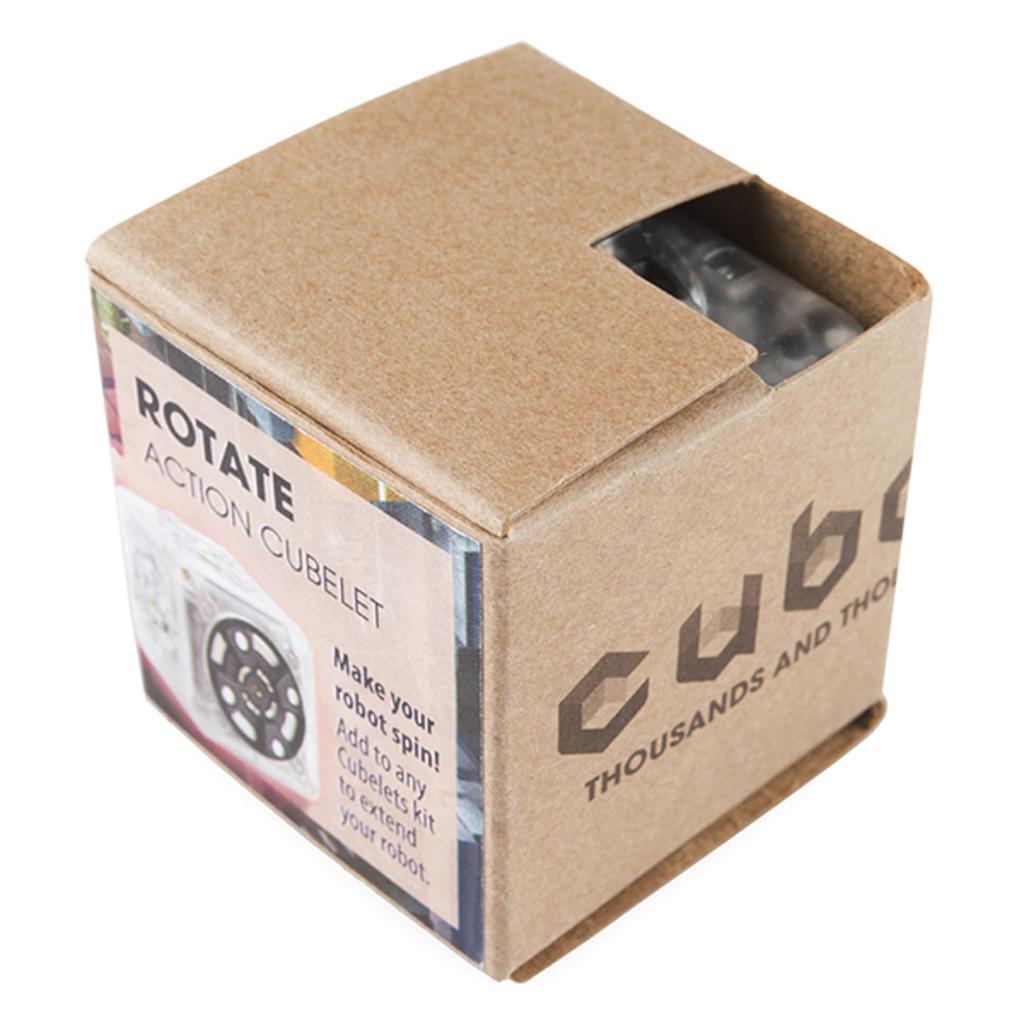What is in the box?
Ensure brevity in your answer.  Action cubelet. What word is on th eleft top side of the box?
Your answer should be compact. Rotate. 